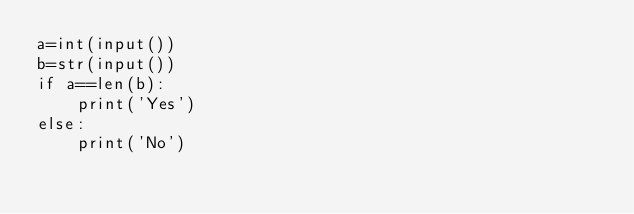Convert code to text. <code><loc_0><loc_0><loc_500><loc_500><_Python_>a=int(input())
b=str(input())
if a==len(b):
    print('Yes')
else:
    print('No')</code> 